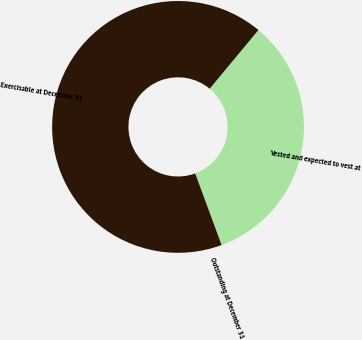Convert chart to OTSL. <chart><loc_0><loc_0><loc_500><loc_500><pie_chart><fcel>Outstanding at December 31<fcel>Vested and expected to vest at<fcel>Exercisable at December 31<nl><fcel>0.02%<fcel>33.33%<fcel>66.65%<nl></chart> 